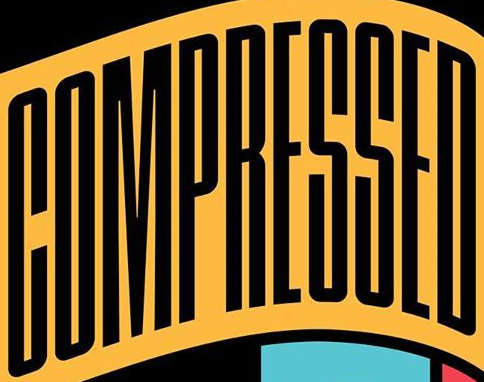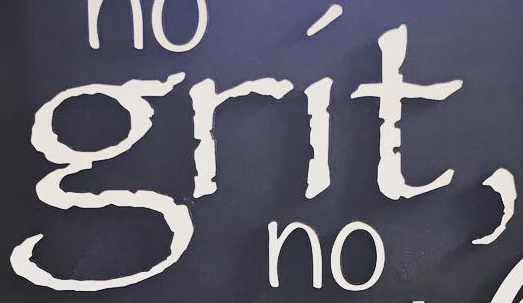Read the text from these images in sequence, separated by a semicolon. COMPRESSED; grít, 